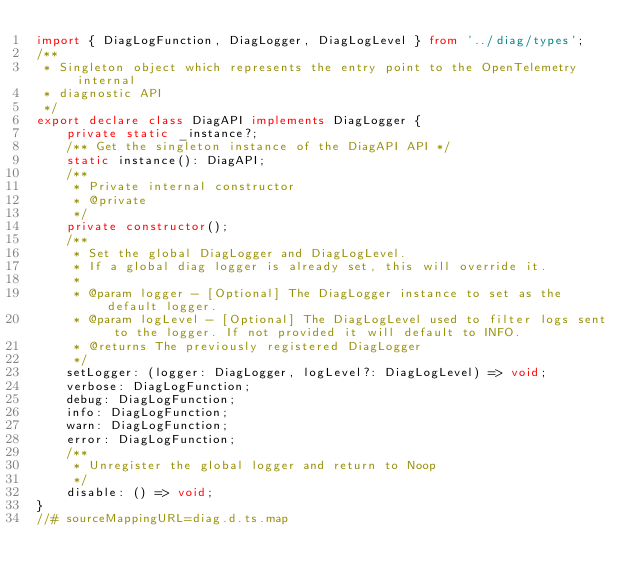Convert code to text. <code><loc_0><loc_0><loc_500><loc_500><_TypeScript_>import { DiagLogFunction, DiagLogger, DiagLogLevel } from '../diag/types';
/**
 * Singleton object which represents the entry point to the OpenTelemetry internal
 * diagnostic API
 */
export declare class DiagAPI implements DiagLogger {
    private static _instance?;
    /** Get the singleton instance of the DiagAPI API */
    static instance(): DiagAPI;
    /**
     * Private internal constructor
     * @private
     */
    private constructor();
    /**
     * Set the global DiagLogger and DiagLogLevel.
     * If a global diag logger is already set, this will override it.
     *
     * @param logger - [Optional] The DiagLogger instance to set as the default logger.
     * @param logLevel - [Optional] The DiagLogLevel used to filter logs sent to the logger. If not provided it will default to INFO.
     * @returns The previously registered DiagLogger
     */
    setLogger: (logger: DiagLogger, logLevel?: DiagLogLevel) => void;
    verbose: DiagLogFunction;
    debug: DiagLogFunction;
    info: DiagLogFunction;
    warn: DiagLogFunction;
    error: DiagLogFunction;
    /**
     * Unregister the global logger and return to Noop
     */
    disable: () => void;
}
//# sourceMappingURL=diag.d.ts.map</code> 